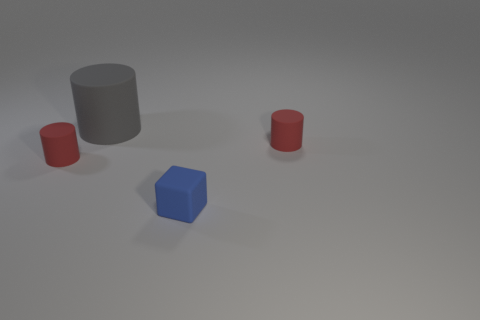Subtract 1 cylinders. How many cylinders are left? 2 Add 2 small red rubber cylinders. How many objects exist? 6 Subtract all cylinders. How many objects are left? 1 Add 1 big gray rubber cylinders. How many big gray rubber cylinders are left? 2 Add 3 green shiny spheres. How many green shiny spheres exist? 3 Subtract 0 green cylinders. How many objects are left? 4 Subtract all red rubber cylinders. Subtract all rubber blocks. How many objects are left? 1 